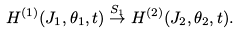<formula> <loc_0><loc_0><loc_500><loc_500>H ^ { ( 1 ) } ( J _ { 1 } , \theta _ { 1 } , t ) \stackrel { S _ { 1 } } { \rightarrow } H ^ { ( 2 ) } ( J _ { 2 } , \theta _ { 2 } , t ) .</formula> 